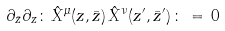<formula> <loc_0><loc_0><loc_500><loc_500>\partial _ { \bar { z } } \partial _ { z } \colon \, { \hat { X } } ^ { \mu } ( z , \bar { z } ) \, { \hat { X } } ^ { \nu } ( z ^ { \prime } , { \bar { z } } ^ { \prime } ) \, \colon \, = \, 0</formula> 